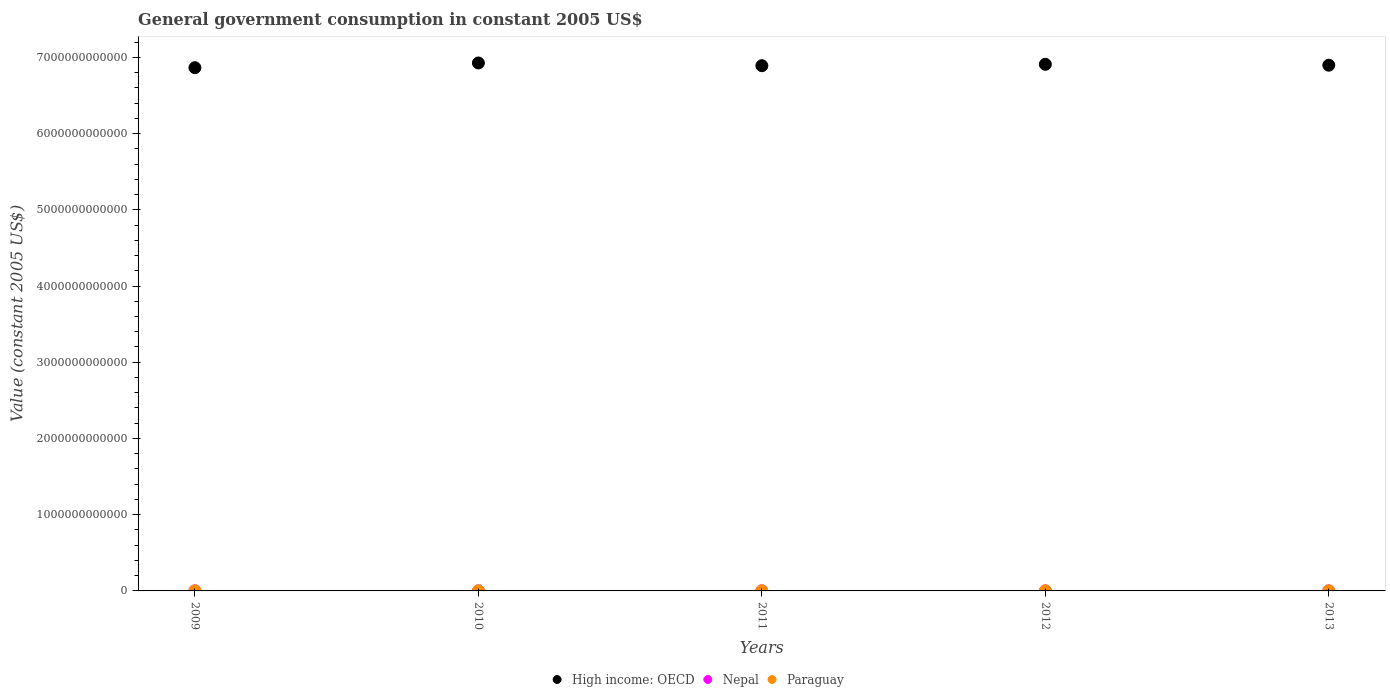What is the government conusmption in High income: OECD in 2010?
Your answer should be very brief. 6.93e+12. Across all years, what is the maximum government conusmption in Nepal?
Provide a succinct answer. 1.18e+09. Across all years, what is the minimum government conusmption in Nepal?
Your response must be concise. 8.85e+08. In which year was the government conusmption in Paraguay maximum?
Make the answer very short. 2013. What is the total government conusmption in High income: OECD in the graph?
Ensure brevity in your answer.  3.45e+13. What is the difference between the government conusmption in Paraguay in 2011 and that in 2013?
Offer a terse response. -3.03e+08. What is the difference between the government conusmption in High income: OECD in 2013 and the government conusmption in Paraguay in 2009?
Your response must be concise. 6.90e+12. What is the average government conusmption in Nepal per year?
Make the answer very short. 1.01e+09. In the year 2011, what is the difference between the government conusmption in Paraguay and government conusmption in High income: OECD?
Your response must be concise. -6.89e+12. What is the ratio of the government conusmption in High income: OECD in 2011 to that in 2012?
Give a very brief answer. 1. Is the difference between the government conusmption in Paraguay in 2011 and 2013 greater than the difference between the government conusmption in High income: OECD in 2011 and 2013?
Offer a terse response. Yes. What is the difference between the highest and the second highest government conusmption in Paraguay?
Give a very brief answer. 5.03e+07. What is the difference between the highest and the lowest government conusmption in Nepal?
Your answer should be compact. 2.91e+08. In how many years, is the government conusmption in High income: OECD greater than the average government conusmption in High income: OECD taken over all years?
Your response must be concise. 2. Is the sum of the government conusmption in Nepal in 2009 and 2011 greater than the maximum government conusmption in Paraguay across all years?
Keep it short and to the point. Yes. Does the government conusmption in High income: OECD monotonically increase over the years?
Provide a succinct answer. No. How many dotlines are there?
Provide a short and direct response. 3. What is the difference between two consecutive major ticks on the Y-axis?
Make the answer very short. 1.00e+12. Does the graph contain any zero values?
Your answer should be compact. No. Does the graph contain grids?
Offer a very short reply. No. Where does the legend appear in the graph?
Ensure brevity in your answer.  Bottom center. What is the title of the graph?
Provide a succinct answer. General government consumption in constant 2005 US$. Does "Dominican Republic" appear as one of the legend labels in the graph?
Offer a very short reply. No. What is the label or title of the X-axis?
Offer a terse response. Years. What is the label or title of the Y-axis?
Provide a succinct answer. Value (constant 2005 US$). What is the Value (constant 2005 US$) of High income: OECD in 2009?
Offer a terse response. 6.86e+12. What is the Value (constant 2005 US$) of Nepal in 2009?
Offer a terse response. 8.85e+08. What is the Value (constant 2005 US$) in Paraguay in 2009?
Provide a succinct answer. 1.02e+09. What is the Value (constant 2005 US$) of High income: OECD in 2010?
Ensure brevity in your answer.  6.93e+12. What is the Value (constant 2005 US$) of Nepal in 2010?
Offer a terse response. 8.97e+08. What is the Value (constant 2005 US$) in Paraguay in 2010?
Your answer should be compact. 1.14e+09. What is the Value (constant 2005 US$) in High income: OECD in 2011?
Keep it short and to the point. 6.89e+12. What is the Value (constant 2005 US$) in Nepal in 2011?
Your answer should be very brief. 1.01e+09. What is the Value (constant 2005 US$) of Paraguay in 2011?
Offer a terse response. 1.21e+09. What is the Value (constant 2005 US$) in High income: OECD in 2012?
Make the answer very short. 6.91e+12. What is the Value (constant 2005 US$) of Nepal in 2012?
Give a very brief answer. 1.18e+09. What is the Value (constant 2005 US$) in Paraguay in 2012?
Offer a very short reply. 1.46e+09. What is the Value (constant 2005 US$) of High income: OECD in 2013?
Offer a terse response. 6.90e+12. What is the Value (constant 2005 US$) in Nepal in 2013?
Give a very brief answer. 1.10e+09. What is the Value (constant 2005 US$) in Paraguay in 2013?
Offer a terse response. 1.51e+09. Across all years, what is the maximum Value (constant 2005 US$) of High income: OECD?
Provide a short and direct response. 6.93e+12. Across all years, what is the maximum Value (constant 2005 US$) of Nepal?
Offer a very short reply. 1.18e+09. Across all years, what is the maximum Value (constant 2005 US$) in Paraguay?
Ensure brevity in your answer.  1.51e+09. Across all years, what is the minimum Value (constant 2005 US$) in High income: OECD?
Give a very brief answer. 6.86e+12. Across all years, what is the minimum Value (constant 2005 US$) of Nepal?
Offer a terse response. 8.85e+08. Across all years, what is the minimum Value (constant 2005 US$) of Paraguay?
Your response must be concise. 1.02e+09. What is the total Value (constant 2005 US$) in High income: OECD in the graph?
Offer a terse response. 3.45e+13. What is the total Value (constant 2005 US$) in Nepal in the graph?
Ensure brevity in your answer.  5.07e+09. What is the total Value (constant 2005 US$) of Paraguay in the graph?
Provide a short and direct response. 6.34e+09. What is the difference between the Value (constant 2005 US$) of High income: OECD in 2009 and that in 2010?
Your answer should be very brief. -6.19e+1. What is the difference between the Value (constant 2005 US$) of Nepal in 2009 and that in 2010?
Make the answer very short. -1.17e+07. What is the difference between the Value (constant 2005 US$) of Paraguay in 2009 and that in 2010?
Offer a terse response. -1.23e+08. What is the difference between the Value (constant 2005 US$) in High income: OECD in 2009 and that in 2011?
Ensure brevity in your answer.  -2.60e+1. What is the difference between the Value (constant 2005 US$) of Nepal in 2009 and that in 2011?
Your answer should be very brief. -1.29e+08. What is the difference between the Value (constant 2005 US$) of Paraguay in 2009 and that in 2011?
Make the answer very short. -1.83e+08. What is the difference between the Value (constant 2005 US$) of High income: OECD in 2009 and that in 2012?
Give a very brief answer. -4.44e+1. What is the difference between the Value (constant 2005 US$) in Nepal in 2009 and that in 2012?
Your answer should be very brief. -2.91e+08. What is the difference between the Value (constant 2005 US$) of Paraguay in 2009 and that in 2012?
Offer a very short reply. -4.36e+08. What is the difference between the Value (constant 2005 US$) in High income: OECD in 2009 and that in 2013?
Keep it short and to the point. -3.27e+1. What is the difference between the Value (constant 2005 US$) of Nepal in 2009 and that in 2013?
Keep it short and to the point. -2.10e+08. What is the difference between the Value (constant 2005 US$) of Paraguay in 2009 and that in 2013?
Offer a very short reply. -4.87e+08. What is the difference between the Value (constant 2005 US$) of High income: OECD in 2010 and that in 2011?
Your answer should be very brief. 3.59e+1. What is the difference between the Value (constant 2005 US$) in Nepal in 2010 and that in 2011?
Offer a terse response. -1.18e+08. What is the difference between the Value (constant 2005 US$) in Paraguay in 2010 and that in 2011?
Give a very brief answer. -6.07e+07. What is the difference between the Value (constant 2005 US$) of High income: OECD in 2010 and that in 2012?
Your response must be concise. 1.75e+1. What is the difference between the Value (constant 2005 US$) of Nepal in 2010 and that in 2012?
Your answer should be very brief. -2.79e+08. What is the difference between the Value (constant 2005 US$) of Paraguay in 2010 and that in 2012?
Ensure brevity in your answer.  -3.14e+08. What is the difference between the Value (constant 2005 US$) of High income: OECD in 2010 and that in 2013?
Keep it short and to the point. 2.92e+1. What is the difference between the Value (constant 2005 US$) of Nepal in 2010 and that in 2013?
Your answer should be compact. -1.98e+08. What is the difference between the Value (constant 2005 US$) of Paraguay in 2010 and that in 2013?
Offer a terse response. -3.64e+08. What is the difference between the Value (constant 2005 US$) of High income: OECD in 2011 and that in 2012?
Provide a short and direct response. -1.84e+1. What is the difference between the Value (constant 2005 US$) of Nepal in 2011 and that in 2012?
Keep it short and to the point. -1.62e+08. What is the difference between the Value (constant 2005 US$) in Paraguay in 2011 and that in 2012?
Your answer should be very brief. -2.53e+08. What is the difference between the Value (constant 2005 US$) in High income: OECD in 2011 and that in 2013?
Your answer should be very brief. -6.66e+09. What is the difference between the Value (constant 2005 US$) of Nepal in 2011 and that in 2013?
Give a very brief answer. -8.09e+07. What is the difference between the Value (constant 2005 US$) in Paraguay in 2011 and that in 2013?
Ensure brevity in your answer.  -3.03e+08. What is the difference between the Value (constant 2005 US$) in High income: OECD in 2012 and that in 2013?
Offer a very short reply. 1.17e+1. What is the difference between the Value (constant 2005 US$) in Nepal in 2012 and that in 2013?
Ensure brevity in your answer.  8.07e+07. What is the difference between the Value (constant 2005 US$) in Paraguay in 2012 and that in 2013?
Your response must be concise. -5.03e+07. What is the difference between the Value (constant 2005 US$) in High income: OECD in 2009 and the Value (constant 2005 US$) in Nepal in 2010?
Give a very brief answer. 6.86e+12. What is the difference between the Value (constant 2005 US$) of High income: OECD in 2009 and the Value (constant 2005 US$) of Paraguay in 2010?
Offer a very short reply. 6.86e+12. What is the difference between the Value (constant 2005 US$) of Nepal in 2009 and the Value (constant 2005 US$) of Paraguay in 2010?
Offer a terse response. -2.59e+08. What is the difference between the Value (constant 2005 US$) in High income: OECD in 2009 and the Value (constant 2005 US$) in Nepal in 2011?
Keep it short and to the point. 6.86e+12. What is the difference between the Value (constant 2005 US$) of High income: OECD in 2009 and the Value (constant 2005 US$) of Paraguay in 2011?
Your answer should be compact. 6.86e+12. What is the difference between the Value (constant 2005 US$) of Nepal in 2009 and the Value (constant 2005 US$) of Paraguay in 2011?
Make the answer very short. -3.20e+08. What is the difference between the Value (constant 2005 US$) in High income: OECD in 2009 and the Value (constant 2005 US$) in Nepal in 2012?
Give a very brief answer. 6.86e+12. What is the difference between the Value (constant 2005 US$) of High income: OECD in 2009 and the Value (constant 2005 US$) of Paraguay in 2012?
Keep it short and to the point. 6.86e+12. What is the difference between the Value (constant 2005 US$) of Nepal in 2009 and the Value (constant 2005 US$) of Paraguay in 2012?
Provide a succinct answer. -5.73e+08. What is the difference between the Value (constant 2005 US$) of High income: OECD in 2009 and the Value (constant 2005 US$) of Nepal in 2013?
Provide a succinct answer. 6.86e+12. What is the difference between the Value (constant 2005 US$) in High income: OECD in 2009 and the Value (constant 2005 US$) in Paraguay in 2013?
Make the answer very short. 6.86e+12. What is the difference between the Value (constant 2005 US$) of Nepal in 2009 and the Value (constant 2005 US$) of Paraguay in 2013?
Keep it short and to the point. -6.24e+08. What is the difference between the Value (constant 2005 US$) in High income: OECD in 2010 and the Value (constant 2005 US$) in Nepal in 2011?
Provide a succinct answer. 6.92e+12. What is the difference between the Value (constant 2005 US$) of High income: OECD in 2010 and the Value (constant 2005 US$) of Paraguay in 2011?
Offer a very short reply. 6.92e+12. What is the difference between the Value (constant 2005 US$) in Nepal in 2010 and the Value (constant 2005 US$) in Paraguay in 2011?
Provide a short and direct response. -3.08e+08. What is the difference between the Value (constant 2005 US$) of High income: OECD in 2010 and the Value (constant 2005 US$) of Nepal in 2012?
Give a very brief answer. 6.92e+12. What is the difference between the Value (constant 2005 US$) of High income: OECD in 2010 and the Value (constant 2005 US$) of Paraguay in 2012?
Offer a very short reply. 6.92e+12. What is the difference between the Value (constant 2005 US$) of Nepal in 2010 and the Value (constant 2005 US$) of Paraguay in 2012?
Your response must be concise. -5.62e+08. What is the difference between the Value (constant 2005 US$) in High income: OECD in 2010 and the Value (constant 2005 US$) in Nepal in 2013?
Your answer should be compact. 6.92e+12. What is the difference between the Value (constant 2005 US$) in High income: OECD in 2010 and the Value (constant 2005 US$) in Paraguay in 2013?
Provide a succinct answer. 6.92e+12. What is the difference between the Value (constant 2005 US$) of Nepal in 2010 and the Value (constant 2005 US$) of Paraguay in 2013?
Ensure brevity in your answer.  -6.12e+08. What is the difference between the Value (constant 2005 US$) of High income: OECD in 2011 and the Value (constant 2005 US$) of Nepal in 2012?
Ensure brevity in your answer.  6.89e+12. What is the difference between the Value (constant 2005 US$) of High income: OECD in 2011 and the Value (constant 2005 US$) of Paraguay in 2012?
Make the answer very short. 6.89e+12. What is the difference between the Value (constant 2005 US$) in Nepal in 2011 and the Value (constant 2005 US$) in Paraguay in 2012?
Your answer should be compact. -4.44e+08. What is the difference between the Value (constant 2005 US$) of High income: OECD in 2011 and the Value (constant 2005 US$) of Nepal in 2013?
Make the answer very short. 6.89e+12. What is the difference between the Value (constant 2005 US$) in High income: OECD in 2011 and the Value (constant 2005 US$) in Paraguay in 2013?
Make the answer very short. 6.89e+12. What is the difference between the Value (constant 2005 US$) of Nepal in 2011 and the Value (constant 2005 US$) of Paraguay in 2013?
Keep it short and to the point. -4.94e+08. What is the difference between the Value (constant 2005 US$) in High income: OECD in 2012 and the Value (constant 2005 US$) in Nepal in 2013?
Your answer should be very brief. 6.91e+12. What is the difference between the Value (constant 2005 US$) of High income: OECD in 2012 and the Value (constant 2005 US$) of Paraguay in 2013?
Keep it short and to the point. 6.91e+12. What is the difference between the Value (constant 2005 US$) in Nepal in 2012 and the Value (constant 2005 US$) in Paraguay in 2013?
Your answer should be very brief. -3.33e+08. What is the average Value (constant 2005 US$) of High income: OECD per year?
Provide a succinct answer. 6.90e+12. What is the average Value (constant 2005 US$) in Nepal per year?
Ensure brevity in your answer.  1.01e+09. What is the average Value (constant 2005 US$) of Paraguay per year?
Offer a terse response. 1.27e+09. In the year 2009, what is the difference between the Value (constant 2005 US$) of High income: OECD and Value (constant 2005 US$) of Nepal?
Give a very brief answer. 6.86e+12. In the year 2009, what is the difference between the Value (constant 2005 US$) in High income: OECD and Value (constant 2005 US$) in Paraguay?
Offer a terse response. 6.86e+12. In the year 2009, what is the difference between the Value (constant 2005 US$) of Nepal and Value (constant 2005 US$) of Paraguay?
Give a very brief answer. -1.37e+08. In the year 2010, what is the difference between the Value (constant 2005 US$) in High income: OECD and Value (constant 2005 US$) in Nepal?
Your response must be concise. 6.93e+12. In the year 2010, what is the difference between the Value (constant 2005 US$) in High income: OECD and Value (constant 2005 US$) in Paraguay?
Your answer should be compact. 6.92e+12. In the year 2010, what is the difference between the Value (constant 2005 US$) in Nepal and Value (constant 2005 US$) in Paraguay?
Give a very brief answer. -2.48e+08. In the year 2011, what is the difference between the Value (constant 2005 US$) in High income: OECD and Value (constant 2005 US$) in Nepal?
Your response must be concise. 6.89e+12. In the year 2011, what is the difference between the Value (constant 2005 US$) of High income: OECD and Value (constant 2005 US$) of Paraguay?
Keep it short and to the point. 6.89e+12. In the year 2011, what is the difference between the Value (constant 2005 US$) of Nepal and Value (constant 2005 US$) of Paraguay?
Provide a short and direct response. -1.91e+08. In the year 2012, what is the difference between the Value (constant 2005 US$) in High income: OECD and Value (constant 2005 US$) in Nepal?
Your answer should be compact. 6.91e+12. In the year 2012, what is the difference between the Value (constant 2005 US$) of High income: OECD and Value (constant 2005 US$) of Paraguay?
Your response must be concise. 6.91e+12. In the year 2012, what is the difference between the Value (constant 2005 US$) in Nepal and Value (constant 2005 US$) in Paraguay?
Offer a very short reply. -2.82e+08. In the year 2013, what is the difference between the Value (constant 2005 US$) of High income: OECD and Value (constant 2005 US$) of Nepal?
Your answer should be compact. 6.90e+12. In the year 2013, what is the difference between the Value (constant 2005 US$) of High income: OECD and Value (constant 2005 US$) of Paraguay?
Give a very brief answer. 6.90e+12. In the year 2013, what is the difference between the Value (constant 2005 US$) in Nepal and Value (constant 2005 US$) in Paraguay?
Your answer should be very brief. -4.13e+08. What is the ratio of the Value (constant 2005 US$) in High income: OECD in 2009 to that in 2010?
Your answer should be very brief. 0.99. What is the ratio of the Value (constant 2005 US$) of Paraguay in 2009 to that in 2010?
Make the answer very short. 0.89. What is the ratio of the Value (constant 2005 US$) of High income: OECD in 2009 to that in 2011?
Make the answer very short. 1. What is the ratio of the Value (constant 2005 US$) in Nepal in 2009 to that in 2011?
Your answer should be compact. 0.87. What is the ratio of the Value (constant 2005 US$) of Paraguay in 2009 to that in 2011?
Give a very brief answer. 0.85. What is the ratio of the Value (constant 2005 US$) of High income: OECD in 2009 to that in 2012?
Your answer should be compact. 0.99. What is the ratio of the Value (constant 2005 US$) of Nepal in 2009 to that in 2012?
Make the answer very short. 0.75. What is the ratio of the Value (constant 2005 US$) in Paraguay in 2009 to that in 2012?
Offer a terse response. 0.7. What is the ratio of the Value (constant 2005 US$) in High income: OECD in 2009 to that in 2013?
Your response must be concise. 1. What is the ratio of the Value (constant 2005 US$) in Nepal in 2009 to that in 2013?
Offer a very short reply. 0.81. What is the ratio of the Value (constant 2005 US$) in Paraguay in 2009 to that in 2013?
Give a very brief answer. 0.68. What is the ratio of the Value (constant 2005 US$) of Nepal in 2010 to that in 2011?
Offer a terse response. 0.88. What is the ratio of the Value (constant 2005 US$) of Paraguay in 2010 to that in 2011?
Offer a terse response. 0.95. What is the ratio of the Value (constant 2005 US$) of Nepal in 2010 to that in 2012?
Your response must be concise. 0.76. What is the ratio of the Value (constant 2005 US$) of Paraguay in 2010 to that in 2012?
Provide a succinct answer. 0.78. What is the ratio of the Value (constant 2005 US$) in Nepal in 2010 to that in 2013?
Offer a very short reply. 0.82. What is the ratio of the Value (constant 2005 US$) of Paraguay in 2010 to that in 2013?
Keep it short and to the point. 0.76. What is the ratio of the Value (constant 2005 US$) in Nepal in 2011 to that in 2012?
Your answer should be compact. 0.86. What is the ratio of the Value (constant 2005 US$) of Paraguay in 2011 to that in 2012?
Give a very brief answer. 0.83. What is the ratio of the Value (constant 2005 US$) of High income: OECD in 2011 to that in 2013?
Your response must be concise. 1. What is the ratio of the Value (constant 2005 US$) in Nepal in 2011 to that in 2013?
Your answer should be compact. 0.93. What is the ratio of the Value (constant 2005 US$) in Paraguay in 2011 to that in 2013?
Your answer should be compact. 0.8. What is the ratio of the Value (constant 2005 US$) in High income: OECD in 2012 to that in 2013?
Provide a succinct answer. 1. What is the ratio of the Value (constant 2005 US$) of Nepal in 2012 to that in 2013?
Offer a terse response. 1.07. What is the ratio of the Value (constant 2005 US$) of Paraguay in 2012 to that in 2013?
Make the answer very short. 0.97. What is the difference between the highest and the second highest Value (constant 2005 US$) of High income: OECD?
Make the answer very short. 1.75e+1. What is the difference between the highest and the second highest Value (constant 2005 US$) of Nepal?
Give a very brief answer. 8.07e+07. What is the difference between the highest and the second highest Value (constant 2005 US$) of Paraguay?
Make the answer very short. 5.03e+07. What is the difference between the highest and the lowest Value (constant 2005 US$) in High income: OECD?
Keep it short and to the point. 6.19e+1. What is the difference between the highest and the lowest Value (constant 2005 US$) in Nepal?
Your answer should be compact. 2.91e+08. What is the difference between the highest and the lowest Value (constant 2005 US$) in Paraguay?
Your answer should be compact. 4.87e+08. 